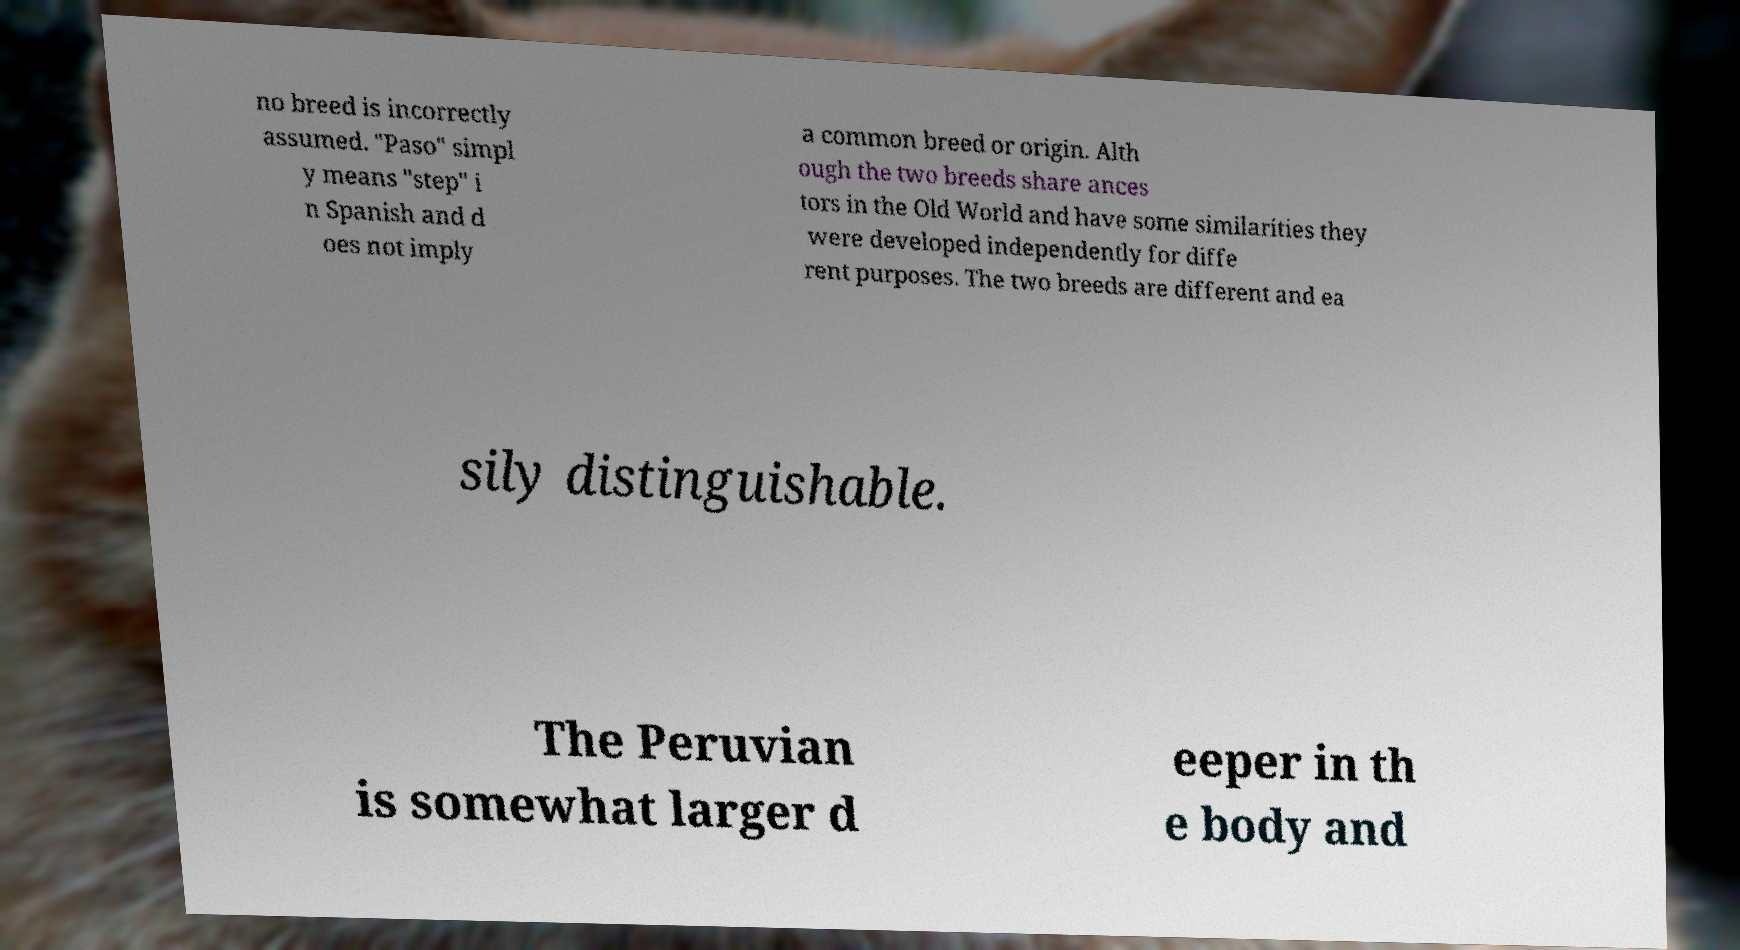Could you extract and type out the text from this image? no breed is incorrectly assumed. "Paso" simpl y means "step" i n Spanish and d oes not imply a common breed or origin. Alth ough the two breeds share ances tors in the Old World and have some similarities they were developed independently for diffe rent purposes. The two breeds are different and ea sily distinguishable. The Peruvian is somewhat larger d eeper in th e body and 